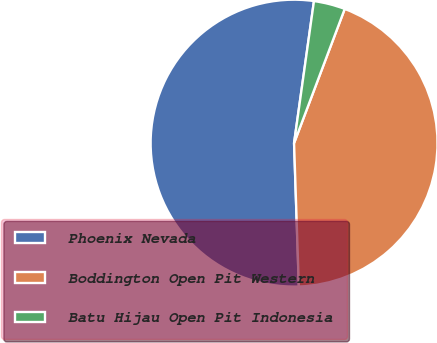<chart> <loc_0><loc_0><loc_500><loc_500><pie_chart><fcel>Phoenix Nevada<fcel>Boddington Open Pit Western<fcel>Batu Hijau Open Pit Indonesia<nl><fcel>52.75%<fcel>43.73%<fcel>3.53%<nl></chart> 